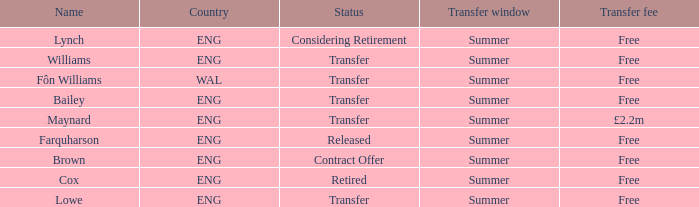What is the name of the free transfer fee with a transfer status and an ENG country? Bailey, Williams, Lowe. 